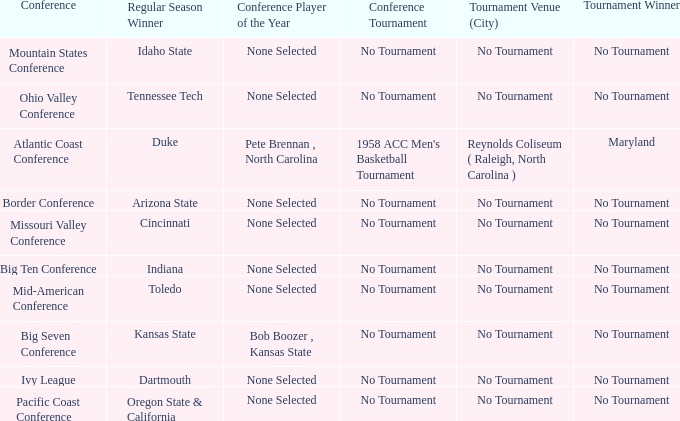What was the conference when Arizona State won the regular season? Border Conference. 